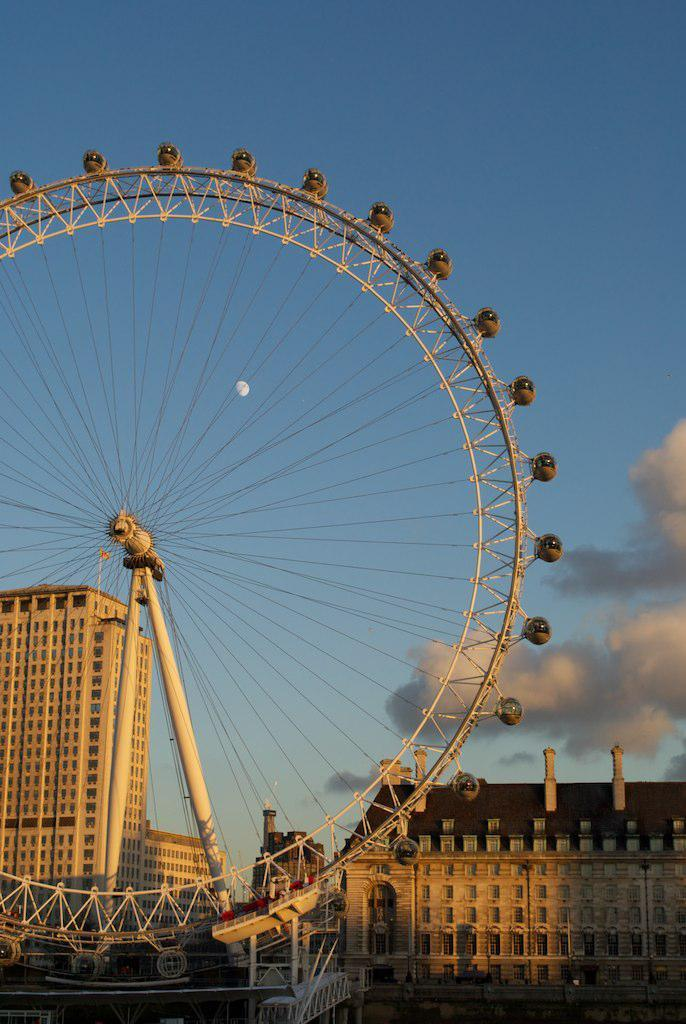What is the main subject of the image? There is an amusement ride in the image. What can be seen in the background of the image? There are buildings and the sky visible in the background of the image. What type of pencil is the stranger holding in the image? There is no stranger or pencil present in the image. What kind of arch can be seen supporting the amusement ride in the image? The image does not show any arches supporting the amusement ride. 